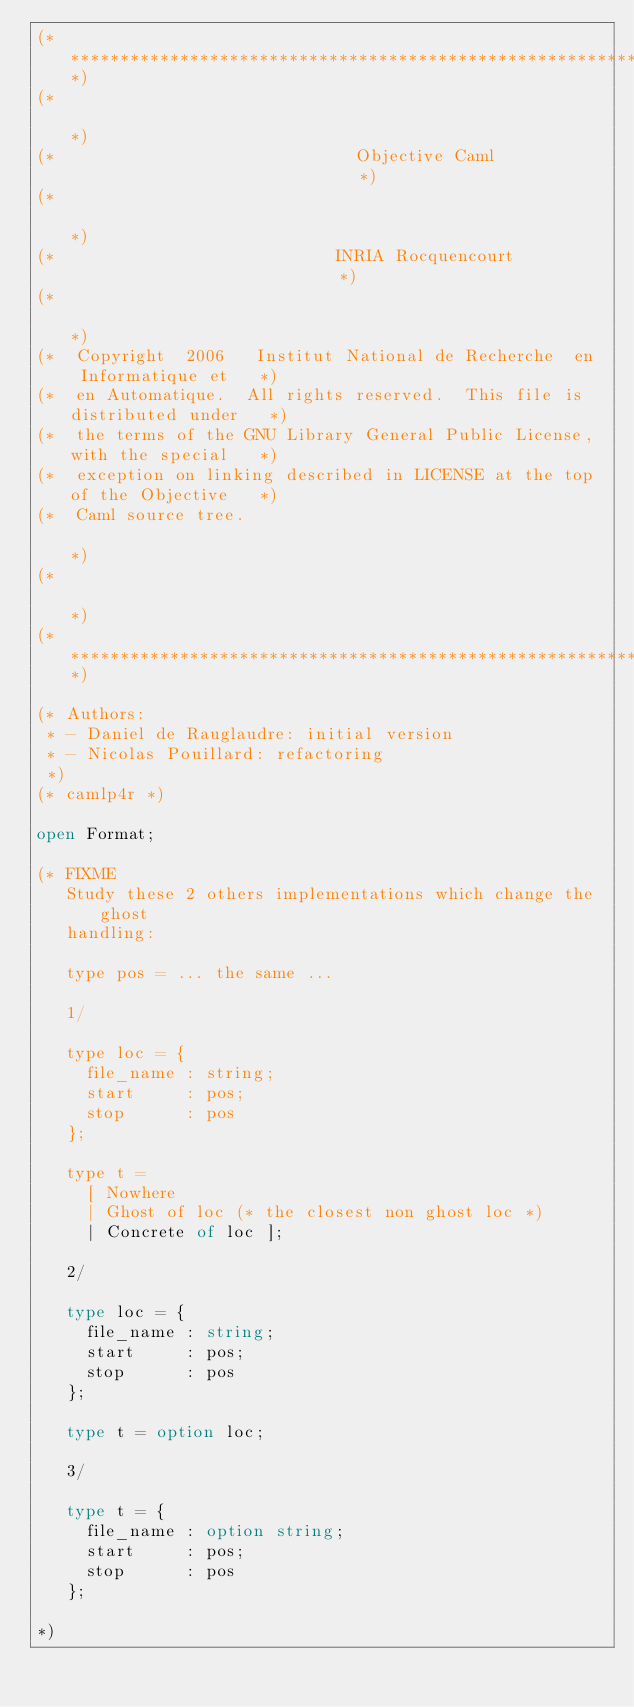Convert code to text. <code><loc_0><loc_0><loc_500><loc_500><_OCaml_>(****************************************************************************)
(*                                                                          *)
(*                              Objective Caml                              *)
(*                                                                          *)
(*                            INRIA Rocquencourt                            *)
(*                                                                          *)
(*  Copyright  2006   Institut National de Recherche  en  Informatique et   *)
(*  en Automatique.  All rights reserved.  This file is distributed under   *)
(*  the terms of the GNU Library General Public License, with the special   *)
(*  exception on linking described in LICENSE at the top of the Objective   *)
(*  Caml source tree.                                                       *)
(*                                                                          *)
(****************************************************************************)

(* Authors:
 * - Daniel de Rauglaudre: initial version
 * - Nicolas Pouillard: refactoring
 *)
(* camlp4r *)

open Format;

(* FIXME
   Study these 2 others implementations which change the ghost
   handling:

   type pos = ... the same ...

   1/

   type loc = {
     file_name : string;
     start     : pos;
     stop      : pos
   };

   type t =
     [ Nowhere
     | Ghost of loc (* the closest non ghost loc *)
     | Concrete of loc ];

   2/

   type loc = {
     file_name : string;
     start     : pos;
     stop      : pos
   };

   type t = option loc;

   3/

   type t = {
     file_name : option string;
     start     : pos;
     stop      : pos
   };

*)
</code> 